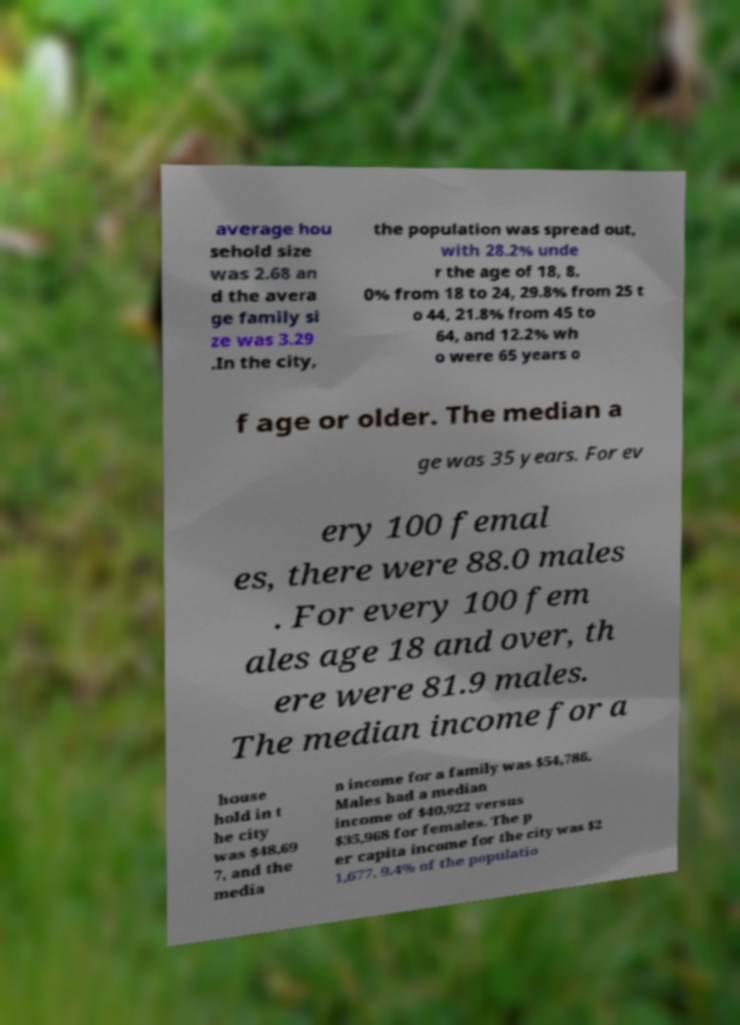What messages or text are displayed in this image? I need them in a readable, typed format. average hou sehold size was 2.68 an d the avera ge family si ze was 3.29 .In the city, the population was spread out, with 28.2% unde r the age of 18, 8. 0% from 18 to 24, 29.8% from 25 t o 44, 21.8% from 45 to 64, and 12.2% wh o were 65 years o f age or older. The median a ge was 35 years. For ev ery 100 femal es, there were 88.0 males . For every 100 fem ales age 18 and over, th ere were 81.9 males. The median income for a house hold in t he city was $48,69 7, and the media n income for a family was $54,786. Males had a median income of $40,922 versus $35,968 for females. The p er capita income for the city was $2 1,677. 9.4% of the populatio 